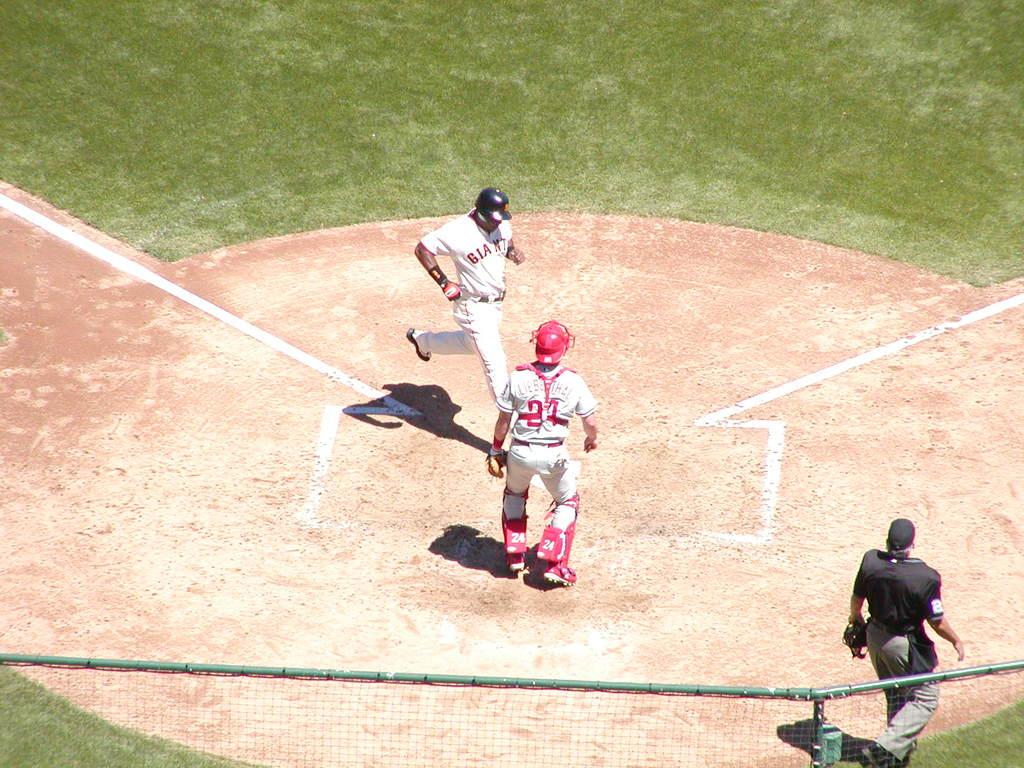<image>
Present a compact description of the photo's key features. A Giants baseball player steps on home plate in front of the catcher and the umpire. 